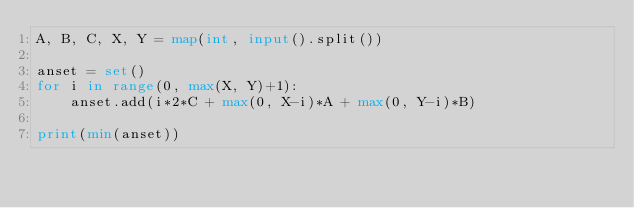<code> <loc_0><loc_0><loc_500><loc_500><_Python_>A, B, C, X, Y = map(int, input().split())

anset = set()
for i in range(0, max(X, Y)+1):
    anset.add(i*2*C + max(0, X-i)*A + max(0, Y-i)*B)

print(min(anset))</code> 